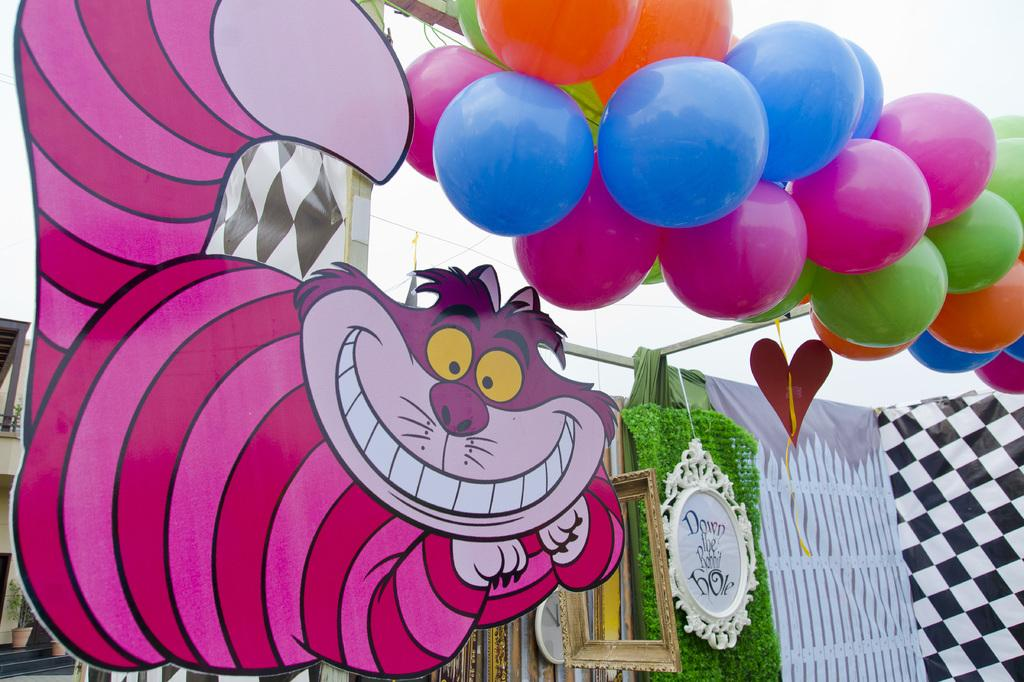What type of board is present in the image? There is an animal board in the image. What decorative items can be seen in the image? There are balloons in the image. What time-keeping device is present in the image? There is a clock in the image. What type of paper item is present in the image? There is a card in the image. What structure is located on the left side of the image? There is a building on the left side of the image. What type of vegetation is on the left side of the image? There are plants on the left side of the image. What type of decision can be seen being made by the hydrant in the image? There is no hydrant present in the image, so no decision can be made by it. What type of credit can be seen being given to the animal board in the image? There is no credit given to the animal board in the image; it is simply a board with animals on it. 